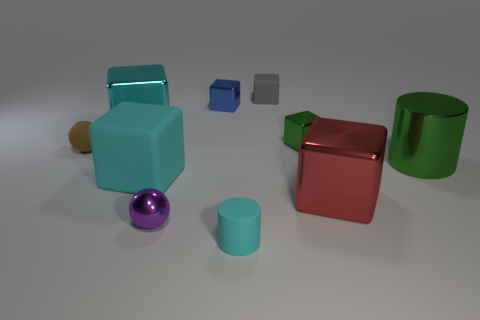Can you describe the colors of the objects present in the image? Certainly! The image showcases objects in several colors: there's a large cyan cube, a small blue cube, a smaller gray cube, a shiny purple sphere, a red shiny cube, and cylinders in shades of green and gold.  Which shapes seem to be in the foreground of the image? The shapes that are most prominent in the foreground are a large cyan cube, a shiny purple sphere, and a small cylinder with a green hue.  Are there any patterns or textures visible on the surfaces of these shapes? The objects in the image exhibit smooth and reflective surfaces without any visible patterns or textures. 